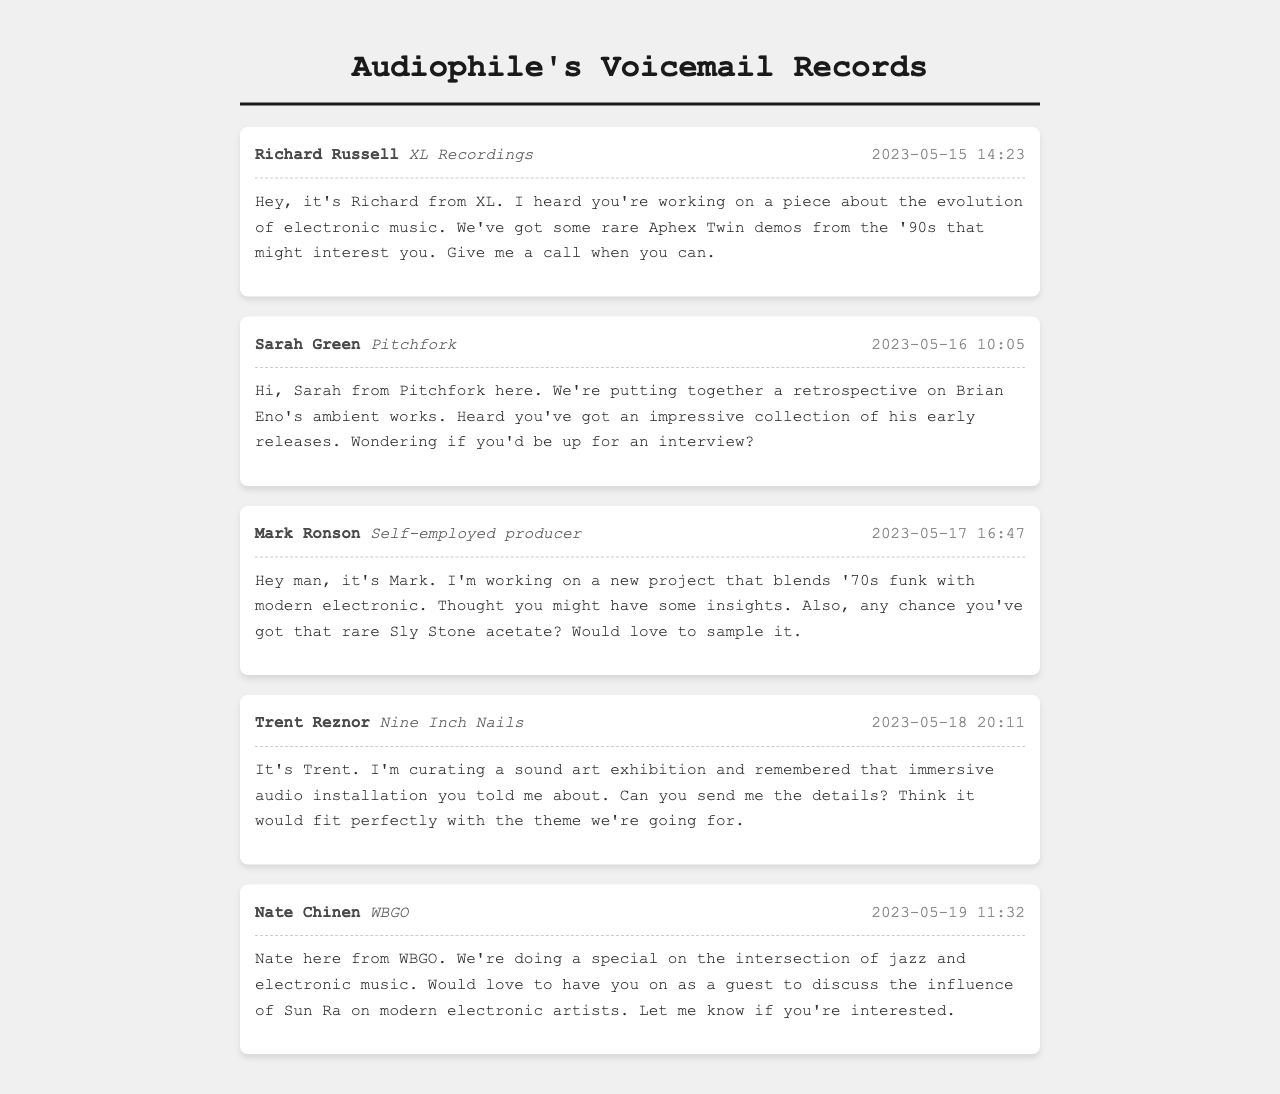What is the name of the caller from XL Recordings? The caller from XL Recordings is Richard Russell.
Answer: Richard Russell When did Sarah Green leave her message? Sarah Green's message was left on May 16, 2023, at 10:05.
Answer: 2023-05-16 10:05 What is Mark Ronson's profession? Mark Ronson identifies himself as a self-employed producer.
Answer: Self-employed producer What project is Trent Reznor curating? Trent Reznor is curating a sound art exhibition.
Answer: Sound art exhibition Who is Nate Chinen affiliated with? Nate Chinen is affiliated with WBGO.
Answer: WBGO How many messages are from record label executives? There are three messages from record label executives (Richard Russell, Sarah Green, Mark Ronson).
Answer: 3 What does Nate want to discuss in his special? Nate wants to discuss the influence of Sun Ra on modern electronic artists.
Answer: Influence of Sun Ra What is the date of Mark Ronson's message? Mark Ronson left his message on May 17, 2023.
Answer: 2023-05-17 Which artist's demos are mentioned in Richard's message? Richard's message mentions rare Aphex Twin demos.
Answer: Aphex Twin 